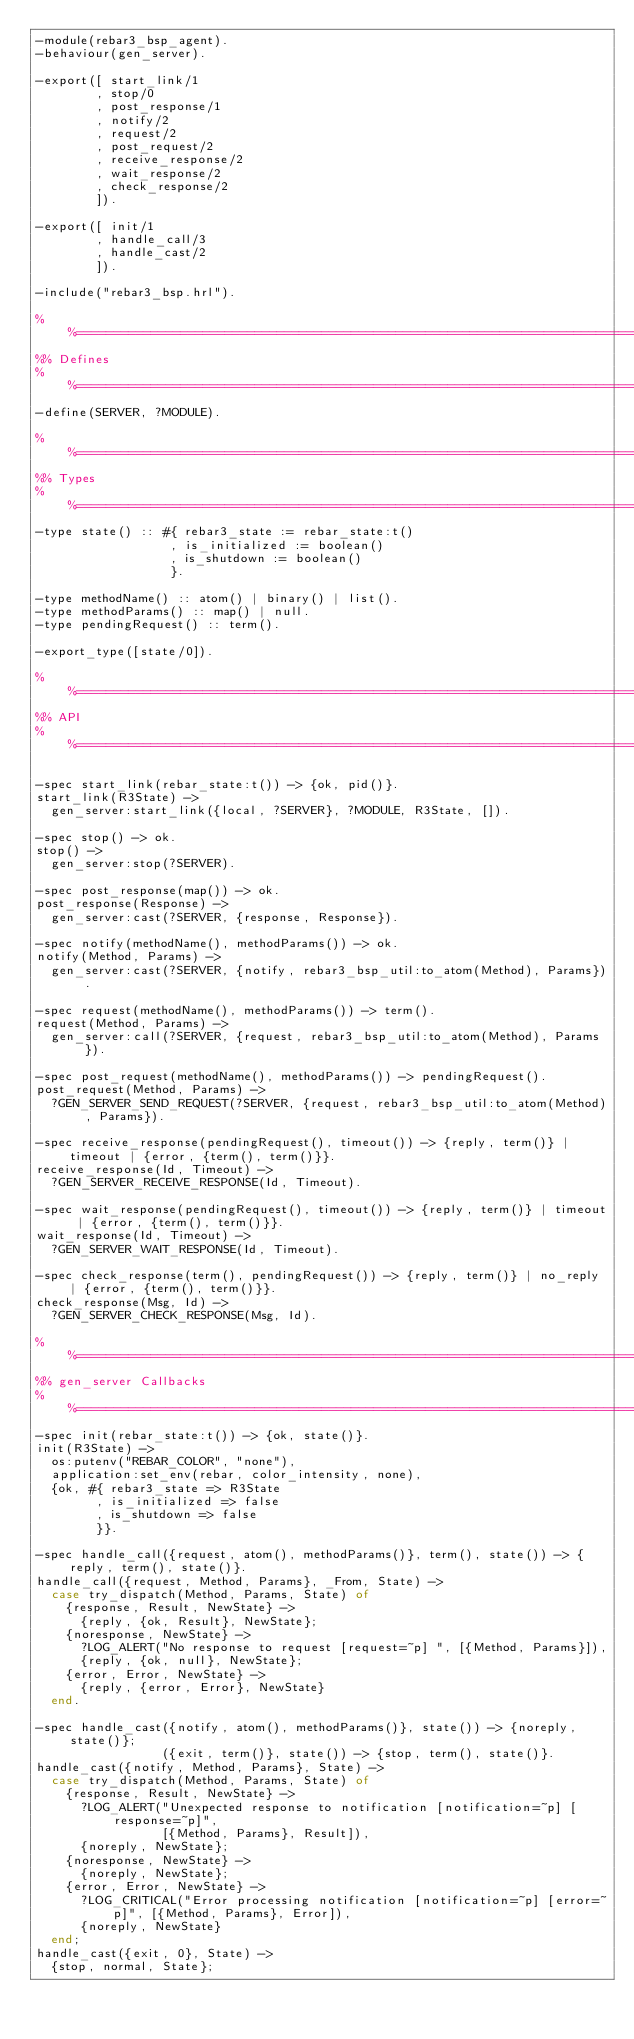<code> <loc_0><loc_0><loc_500><loc_500><_Erlang_>-module(rebar3_bsp_agent).
-behaviour(gen_server).

-export([ start_link/1
        , stop/0
        , post_response/1
        , notify/2
        , request/2
        , post_request/2
        , receive_response/2
        , wait_response/2
        , check_response/2
        ]).

-export([ init/1
        , handle_call/3
        , handle_cast/2
        ]).

-include("rebar3_bsp.hrl").

%%==============================================================================
%% Defines
%%==============================================================================
-define(SERVER, ?MODULE).

%%==============================================================================
%% Types
%%==============================================================================
-type state() :: #{ rebar3_state := rebar_state:t()
                  , is_initialized := boolean()
                  , is_shutdown := boolean()
                  }.

-type methodName() :: atom() | binary() | list().
-type methodParams() :: map() | null.
-type pendingRequest() :: term().

-export_type([state/0]).

%%==============================================================================
%% API
%%==============================================================================

-spec start_link(rebar_state:t()) -> {ok, pid()}.
start_link(R3State) ->
  gen_server:start_link({local, ?SERVER}, ?MODULE, R3State, []).

-spec stop() -> ok.
stop() ->
  gen_server:stop(?SERVER).

-spec post_response(map()) -> ok.
post_response(Response) ->
  gen_server:cast(?SERVER, {response, Response}).

-spec notify(methodName(), methodParams()) -> ok.
notify(Method, Params) ->
  gen_server:cast(?SERVER, {notify, rebar3_bsp_util:to_atom(Method), Params}).

-spec request(methodName(), methodParams()) -> term().
request(Method, Params) ->
  gen_server:call(?SERVER, {request, rebar3_bsp_util:to_atom(Method), Params}).

-spec post_request(methodName(), methodParams()) -> pendingRequest().
post_request(Method, Params) ->
  ?GEN_SERVER_SEND_REQUEST(?SERVER, {request, rebar3_bsp_util:to_atom(Method), Params}).

-spec receive_response(pendingRequest(), timeout()) -> {reply, term()} | timeout | {error, {term(), term()}}.
receive_response(Id, Timeout) ->
  ?GEN_SERVER_RECEIVE_RESPONSE(Id, Timeout).

-spec wait_response(pendingRequest(), timeout()) -> {reply, term()} | timeout | {error, {term(), term()}}.
wait_response(Id, Timeout) ->
  ?GEN_SERVER_WAIT_RESPONSE(Id, Timeout).

-spec check_response(term(), pendingRequest()) -> {reply, term()} | no_reply | {error, {term(), term()}}.
check_response(Msg, Id) ->
  ?GEN_SERVER_CHECK_RESPONSE(Msg, Id).

%%==============================================================================
%% gen_server Callbacks
%%==============================================================================
-spec init(rebar_state:t()) -> {ok, state()}.
init(R3State) ->
  os:putenv("REBAR_COLOR", "none"),
  application:set_env(rebar, color_intensity, none),
  {ok, #{ rebar3_state => R3State
        , is_initialized => false
        , is_shutdown => false
        }}.

-spec handle_call({request, atom(), methodParams()}, term(), state()) -> {reply, term(), state()}.
handle_call({request, Method, Params}, _From, State) ->
  case try_dispatch(Method, Params, State) of
    {response, Result, NewState} ->
      {reply, {ok, Result}, NewState};
    {noresponse, NewState} ->
      ?LOG_ALERT("No response to request [request=~p] ", [{Method, Params}]),
      {reply, {ok, null}, NewState};
    {error, Error, NewState} ->
      {reply, {error, Error}, NewState}
  end.

-spec handle_cast({notify, atom(), methodParams()}, state()) -> {noreply, state()};
                 ({exit, term()}, state()) -> {stop, term(), state()}.
handle_cast({notify, Method, Params}, State) ->
  case try_dispatch(Method, Params, State) of
    {response, Result, NewState} ->
      ?LOG_ALERT("Unexpected response to notification [notification=~p] [response=~p]",
                 [{Method, Params}, Result]),
      {noreply, NewState};
    {noresponse, NewState} ->
      {noreply, NewState};
    {error, Error, NewState} ->
      ?LOG_CRITICAL("Error processing notification [notification=~p] [error=~p]", [{Method, Params}, Error]),
      {noreply, NewState}
  end;
handle_cast({exit, 0}, State) ->
  {stop, normal, State};</code> 